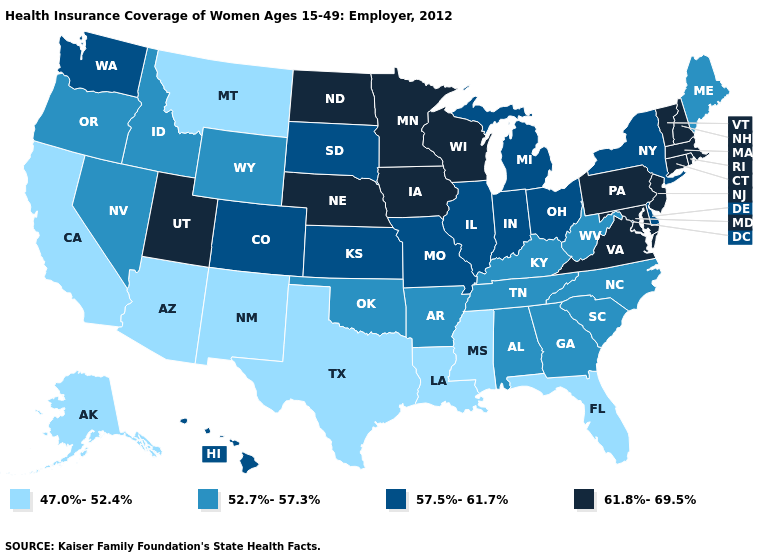What is the highest value in states that border Oklahoma?
Be succinct. 57.5%-61.7%. Among the states that border Nebraska , does Missouri have the lowest value?
Write a very short answer. No. Name the states that have a value in the range 47.0%-52.4%?
Quick response, please. Alaska, Arizona, California, Florida, Louisiana, Mississippi, Montana, New Mexico, Texas. Name the states that have a value in the range 47.0%-52.4%?
Write a very short answer. Alaska, Arizona, California, Florida, Louisiana, Mississippi, Montana, New Mexico, Texas. Does Pennsylvania have a higher value than Tennessee?
Quick response, please. Yes. What is the highest value in the MidWest ?
Concise answer only. 61.8%-69.5%. Does Rhode Island have a lower value than Arkansas?
Quick response, please. No. What is the value of Oregon?
Write a very short answer. 52.7%-57.3%. How many symbols are there in the legend?
Be succinct. 4. What is the lowest value in the USA?
Be succinct. 47.0%-52.4%. What is the lowest value in states that border Missouri?
Concise answer only. 52.7%-57.3%. Name the states that have a value in the range 47.0%-52.4%?
Quick response, please. Alaska, Arizona, California, Florida, Louisiana, Mississippi, Montana, New Mexico, Texas. Which states have the lowest value in the MidWest?
Concise answer only. Illinois, Indiana, Kansas, Michigan, Missouri, Ohio, South Dakota. Among the states that border New Mexico , which have the highest value?
Concise answer only. Utah. 